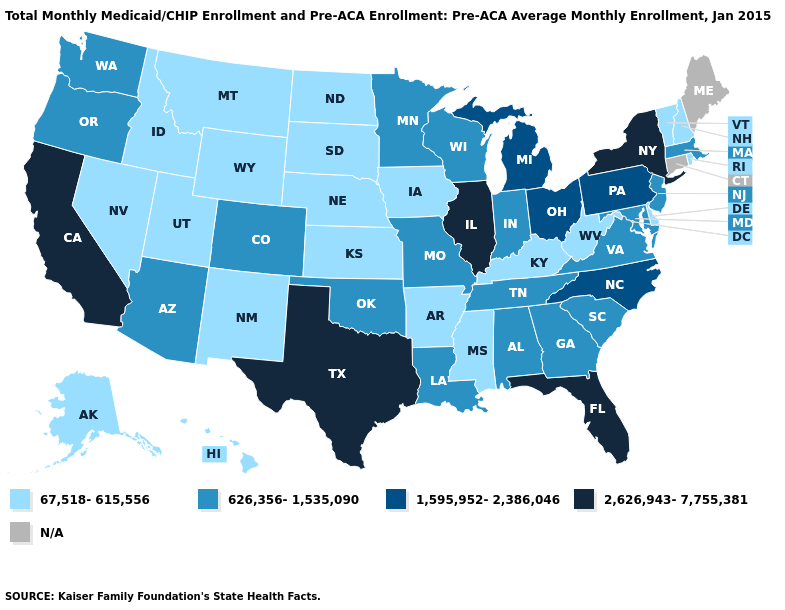Name the states that have a value in the range 1,595,952-2,386,046?
Keep it brief. Michigan, North Carolina, Ohio, Pennsylvania. What is the value of Kentucky?
Write a very short answer. 67,518-615,556. What is the value of Minnesota?
Short answer required. 626,356-1,535,090. Name the states that have a value in the range 626,356-1,535,090?
Give a very brief answer. Alabama, Arizona, Colorado, Georgia, Indiana, Louisiana, Maryland, Massachusetts, Minnesota, Missouri, New Jersey, Oklahoma, Oregon, South Carolina, Tennessee, Virginia, Washington, Wisconsin. Among the states that border Texas , does Oklahoma have the highest value?
Concise answer only. Yes. Among the states that border Connecticut , which have the lowest value?
Be succinct. Rhode Island. Among the states that border Minnesota , which have the lowest value?
Concise answer only. Iowa, North Dakota, South Dakota. Which states have the highest value in the USA?
Concise answer only. California, Florida, Illinois, New York, Texas. What is the value of Virginia?
Concise answer only. 626,356-1,535,090. What is the lowest value in the South?
Quick response, please. 67,518-615,556. What is the value of Rhode Island?
Answer briefly. 67,518-615,556. What is the highest value in states that border Utah?
Give a very brief answer. 626,356-1,535,090. Name the states that have a value in the range 2,626,943-7,755,381?
Answer briefly. California, Florida, Illinois, New York, Texas. Does California have the highest value in the West?
Be succinct. Yes. Does the first symbol in the legend represent the smallest category?
Concise answer only. Yes. 